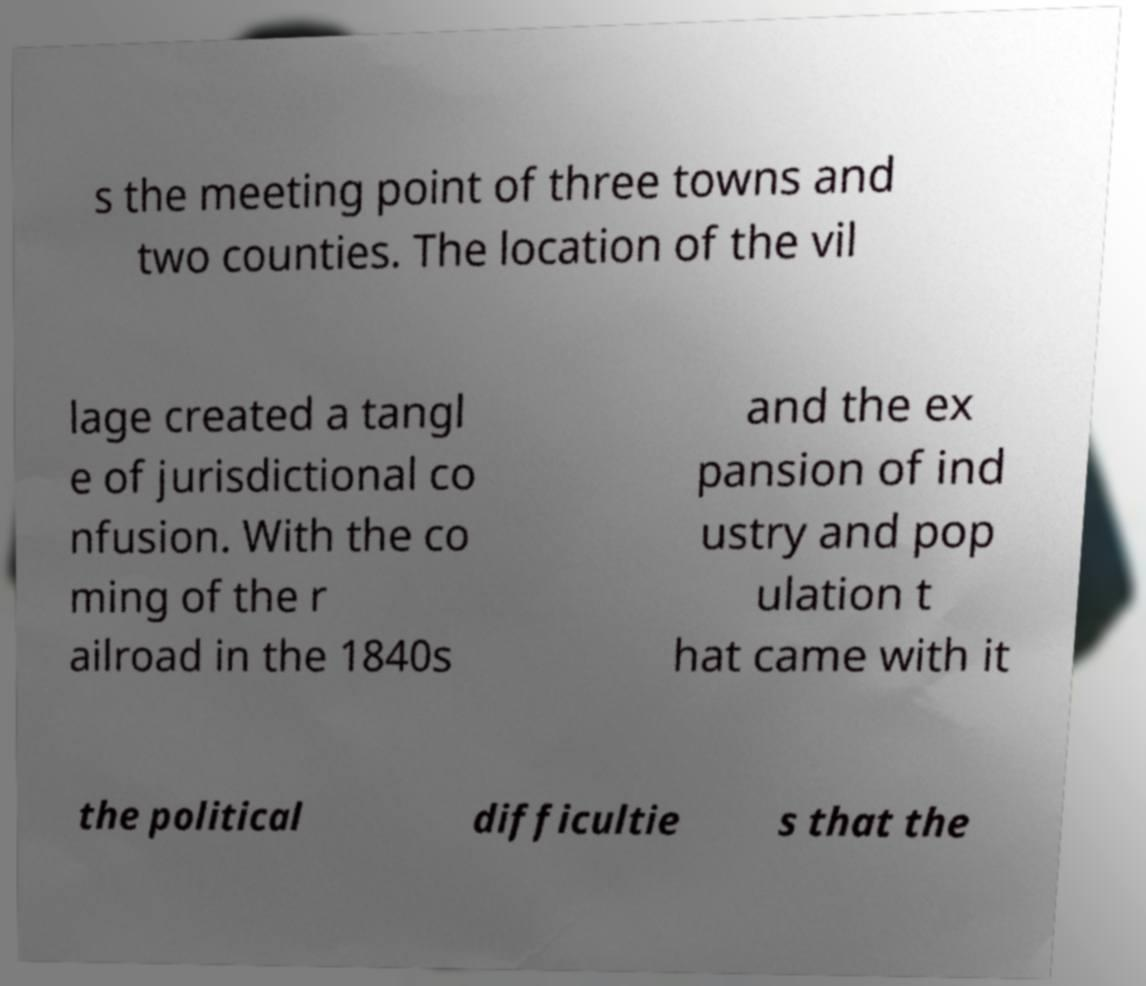Could you extract and type out the text from this image? s the meeting point of three towns and two counties. The location of the vil lage created a tangl e of jurisdictional co nfusion. With the co ming of the r ailroad in the 1840s and the ex pansion of ind ustry and pop ulation t hat came with it the political difficultie s that the 